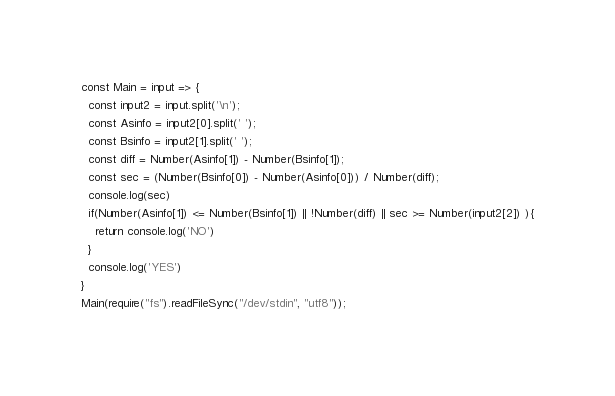Convert code to text. <code><loc_0><loc_0><loc_500><loc_500><_JavaScript_>const Main = input => {
  const input2 = input.split('\n');
  const Asinfo = input2[0].split(' ');
  const Bsinfo = input2[1].split(' ');
  const diff = Number(Asinfo[1]) - Number(Bsinfo[1]);
  const sec = (Number(Bsinfo[0]) - Number(Asinfo[0])) / Number(diff);
  console.log(sec)
  if(Number(Asinfo[1]) <= Number(Bsinfo[1]) || !Number(diff) || sec >= Number(input2[2]) ){
    return console.log('NO')
  }
  console.log('YES')
}
Main(require("fs").readFileSync("/dev/stdin", "utf8"));</code> 